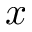Convert formula to latex. <formula><loc_0><loc_0><loc_500><loc_500>x</formula> 